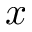Convert formula to latex. <formula><loc_0><loc_0><loc_500><loc_500>x</formula> 